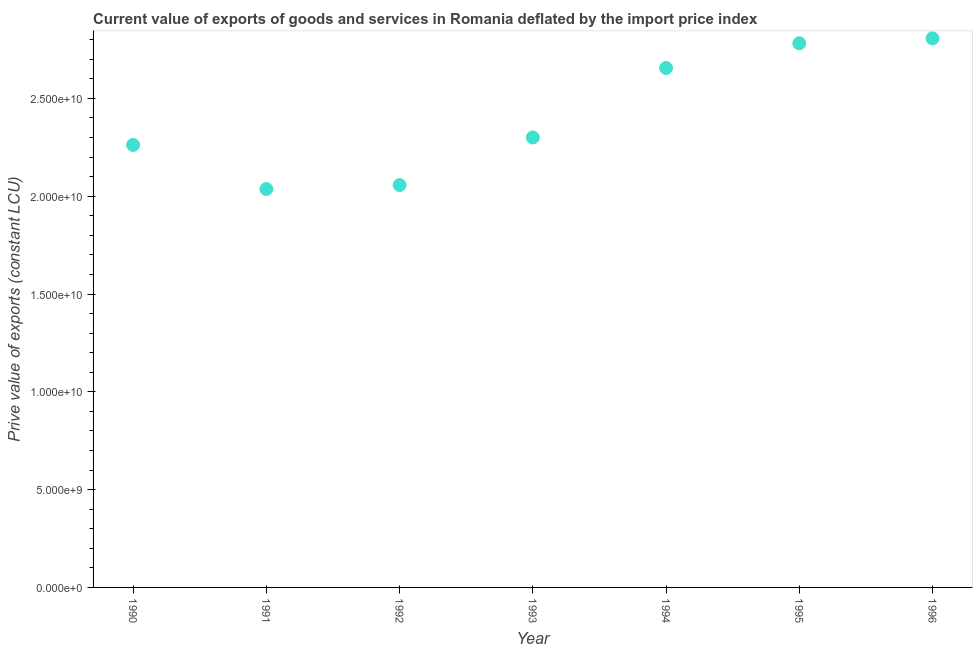What is the price value of exports in 1991?
Ensure brevity in your answer.  2.04e+1. Across all years, what is the maximum price value of exports?
Provide a succinct answer. 2.81e+1. Across all years, what is the minimum price value of exports?
Offer a terse response. 2.04e+1. In which year was the price value of exports minimum?
Your answer should be compact. 1991. What is the sum of the price value of exports?
Give a very brief answer. 1.69e+11. What is the difference between the price value of exports in 1993 and 1994?
Your answer should be compact. -3.55e+09. What is the average price value of exports per year?
Keep it short and to the point. 2.41e+1. What is the median price value of exports?
Your answer should be very brief. 2.30e+1. In how many years, is the price value of exports greater than 9000000000 LCU?
Provide a succinct answer. 7. Do a majority of the years between 1996 and 1991 (inclusive) have price value of exports greater than 11000000000 LCU?
Offer a very short reply. Yes. What is the ratio of the price value of exports in 1990 to that in 1992?
Provide a short and direct response. 1.1. What is the difference between the highest and the second highest price value of exports?
Your answer should be very brief. 2.51e+08. What is the difference between the highest and the lowest price value of exports?
Keep it short and to the point. 7.70e+09. Does the price value of exports monotonically increase over the years?
Make the answer very short. No. How many years are there in the graph?
Offer a terse response. 7. What is the difference between two consecutive major ticks on the Y-axis?
Keep it short and to the point. 5.00e+09. What is the title of the graph?
Make the answer very short. Current value of exports of goods and services in Romania deflated by the import price index. What is the label or title of the Y-axis?
Offer a very short reply. Prive value of exports (constant LCU). What is the Prive value of exports (constant LCU) in 1990?
Your response must be concise. 2.26e+1. What is the Prive value of exports (constant LCU) in 1991?
Your response must be concise. 2.04e+1. What is the Prive value of exports (constant LCU) in 1992?
Make the answer very short. 2.06e+1. What is the Prive value of exports (constant LCU) in 1993?
Your answer should be compact. 2.30e+1. What is the Prive value of exports (constant LCU) in 1994?
Provide a succinct answer. 2.66e+1. What is the Prive value of exports (constant LCU) in 1995?
Give a very brief answer. 2.78e+1. What is the Prive value of exports (constant LCU) in 1996?
Ensure brevity in your answer.  2.81e+1. What is the difference between the Prive value of exports (constant LCU) in 1990 and 1991?
Your answer should be compact. 2.25e+09. What is the difference between the Prive value of exports (constant LCU) in 1990 and 1992?
Offer a terse response. 2.05e+09. What is the difference between the Prive value of exports (constant LCU) in 1990 and 1993?
Provide a succinct answer. -3.81e+08. What is the difference between the Prive value of exports (constant LCU) in 1990 and 1994?
Provide a short and direct response. -3.93e+09. What is the difference between the Prive value of exports (constant LCU) in 1990 and 1995?
Provide a short and direct response. -5.20e+09. What is the difference between the Prive value of exports (constant LCU) in 1990 and 1996?
Give a very brief answer. -5.45e+09. What is the difference between the Prive value of exports (constant LCU) in 1991 and 1992?
Ensure brevity in your answer.  -2.03e+08. What is the difference between the Prive value of exports (constant LCU) in 1991 and 1993?
Offer a very short reply. -2.63e+09. What is the difference between the Prive value of exports (constant LCU) in 1991 and 1994?
Your response must be concise. -6.19e+09. What is the difference between the Prive value of exports (constant LCU) in 1991 and 1995?
Your answer should be very brief. -7.45e+09. What is the difference between the Prive value of exports (constant LCU) in 1991 and 1996?
Make the answer very short. -7.70e+09. What is the difference between the Prive value of exports (constant LCU) in 1992 and 1993?
Offer a very short reply. -2.43e+09. What is the difference between the Prive value of exports (constant LCU) in 1992 and 1994?
Your answer should be very brief. -5.98e+09. What is the difference between the Prive value of exports (constant LCU) in 1992 and 1995?
Your answer should be very brief. -7.25e+09. What is the difference between the Prive value of exports (constant LCU) in 1992 and 1996?
Offer a terse response. -7.50e+09. What is the difference between the Prive value of exports (constant LCU) in 1993 and 1994?
Provide a succinct answer. -3.55e+09. What is the difference between the Prive value of exports (constant LCU) in 1993 and 1995?
Provide a succinct answer. -4.82e+09. What is the difference between the Prive value of exports (constant LCU) in 1993 and 1996?
Your response must be concise. -5.07e+09. What is the difference between the Prive value of exports (constant LCU) in 1994 and 1995?
Your response must be concise. -1.26e+09. What is the difference between the Prive value of exports (constant LCU) in 1994 and 1996?
Offer a very short reply. -1.52e+09. What is the difference between the Prive value of exports (constant LCU) in 1995 and 1996?
Ensure brevity in your answer.  -2.51e+08. What is the ratio of the Prive value of exports (constant LCU) in 1990 to that in 1991?
Offer a terse response. 1.11. What is the ratio of the Prive value of exports (constant LCU) in 1990 to that in 1992?
Provide a succinct answer. 1.1. What is the ratio of the Prive value of exports (constant LCU) in 1990 to that in 1994?
Give a very brief answer. 0.85. What is the ratio of the Prive value of exports (constant LCU) in 1990 to that in 1995?
Provide a short and direct response. 0.81. What is the ratio of the Prive value of exports (constant LCU) in 1990 to that in 1996?
Provide a short and direct response. 0.81. What is the ratio of the Prive value of exports (constant LCU) in 1991 to that in 1992?
Ensure brevity in your answer.  0.99. What is the ratio of the Prive value of exports (constant LCU) in 1991 to that in 1993?
Offer a terse response. 0.89. What is the ratio of the Prive value of exports (constant LCU) in 1991 to that in 1994?
Your answer should be compact. 0.77. What is the ratio of the Prive value of exports (constant LCU) in 1991 to that in 1995?
Your answer should be compact. 0.73. What is the ratio of the Prive value of exports (constant LCU) in 1991 to that in 1996?
Provide a succinct answer. 0.73. What is the ratio of the Prive value of exports (constant LCU) in 1992 to that in 1993?
Ensure brevity in your answer.  0.89. What is the ratio of the Prive value of exports (constant LCU) in 1992 to that in 1994?
Provide a succinct answer. 0.78. What is the ratio of the Prive value of exports (constant LCU) in 1992 to that in 1995?
Your response must be concise. 0.74. What is the ratio of the Prive value of exports (constant LCU) in 1992 to that in 1996?
Provide a succinct answer. 0.73. What is the ratio of the Prive value of exports (constant LCU) in 1993 to that in 1994?
Your answer should be compact. 0.87. What is the ratio of the Prive value of exports (constant LCU) in 1993 to that in 1995?
Ensure brevity in your answer.  0.83. What is the ratio of the Prive value of exports (constant LCU) in 1993 to that in 1996?
Offer a terse response. 0.82. What is the ratio of the Prive value of exports (constant LCU) in 1994 to that in 1995?
Your answer should be compact. 0.95. What is the ratio of the Prive value of exports (constant LCU) in 1994 to that in 1996?
Provide a succinct answer. 0.95. 